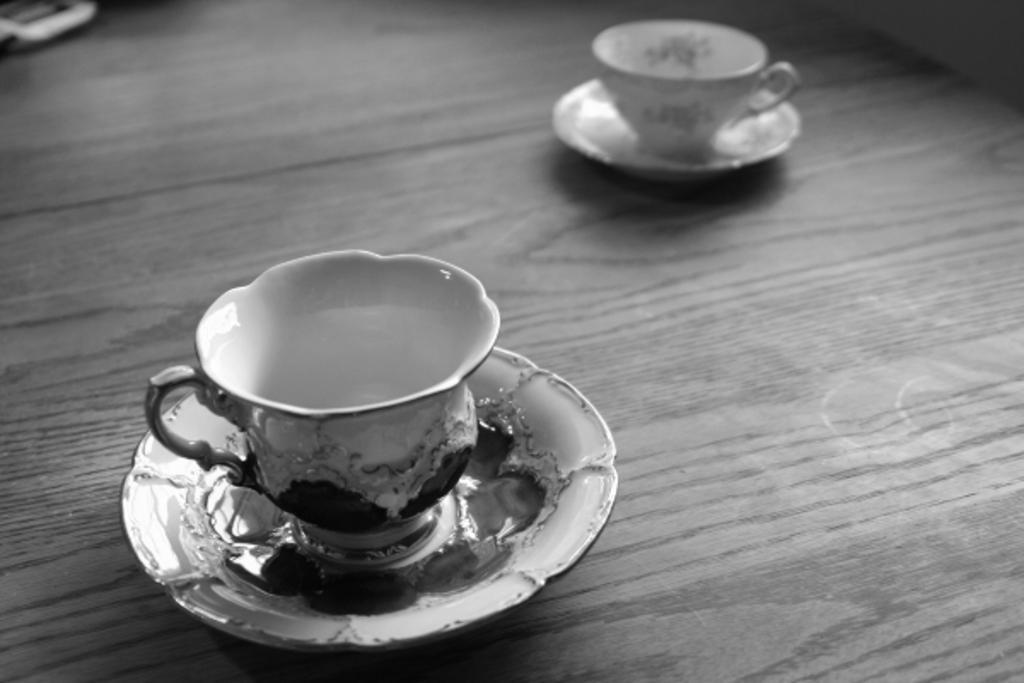In one or two sentences, can you explain what this image depicts? In this image,there are cups of teas and their a plate,There is a floor of brown color. 